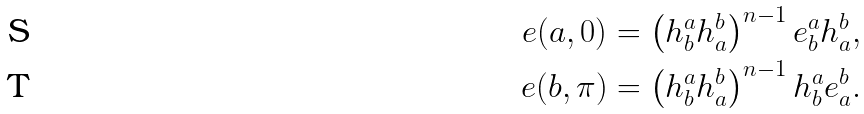Convert formula to latex. <formula><loc_0><loc_0><loc_500><loc_500>e ( a , 0 ) & = \left ( h _ { b } ^ { a } h _ { a } ^ { b } \right ) ^ { n - 1 } e _ { b } ^ { a } h _ { a } ^ { b } , \\ e ( b , \pi ) & = \left ( h _ { b } ^ { a } h _ { a } ^ { b } \right ) ^ { n - 1 } h _ { b } ^ { a } e _ { a } ^ { b } .</formula> 